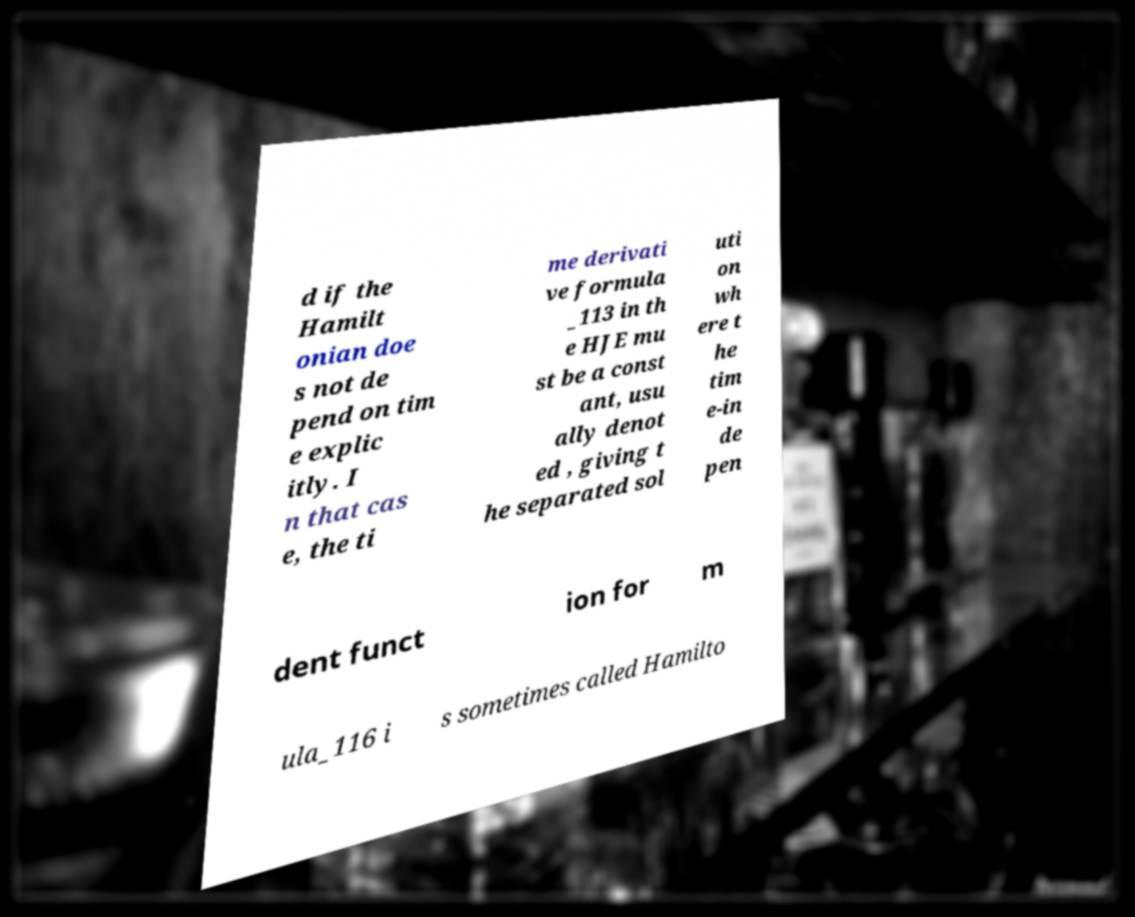For documentation purposes, I need the text within this image transcribed. Could you provide that? d if the Hamilt onian doe s not de pend on tim e explic itly. I n that cas e, the ti me derivati ve formula _113 in th e HJE mu st be a const ant, usu ally denot ed , giving t he separated sol uti on wh ere t he tim e-in de pen dent funct ion for m ula_116 i s sometimes called Hamilto 